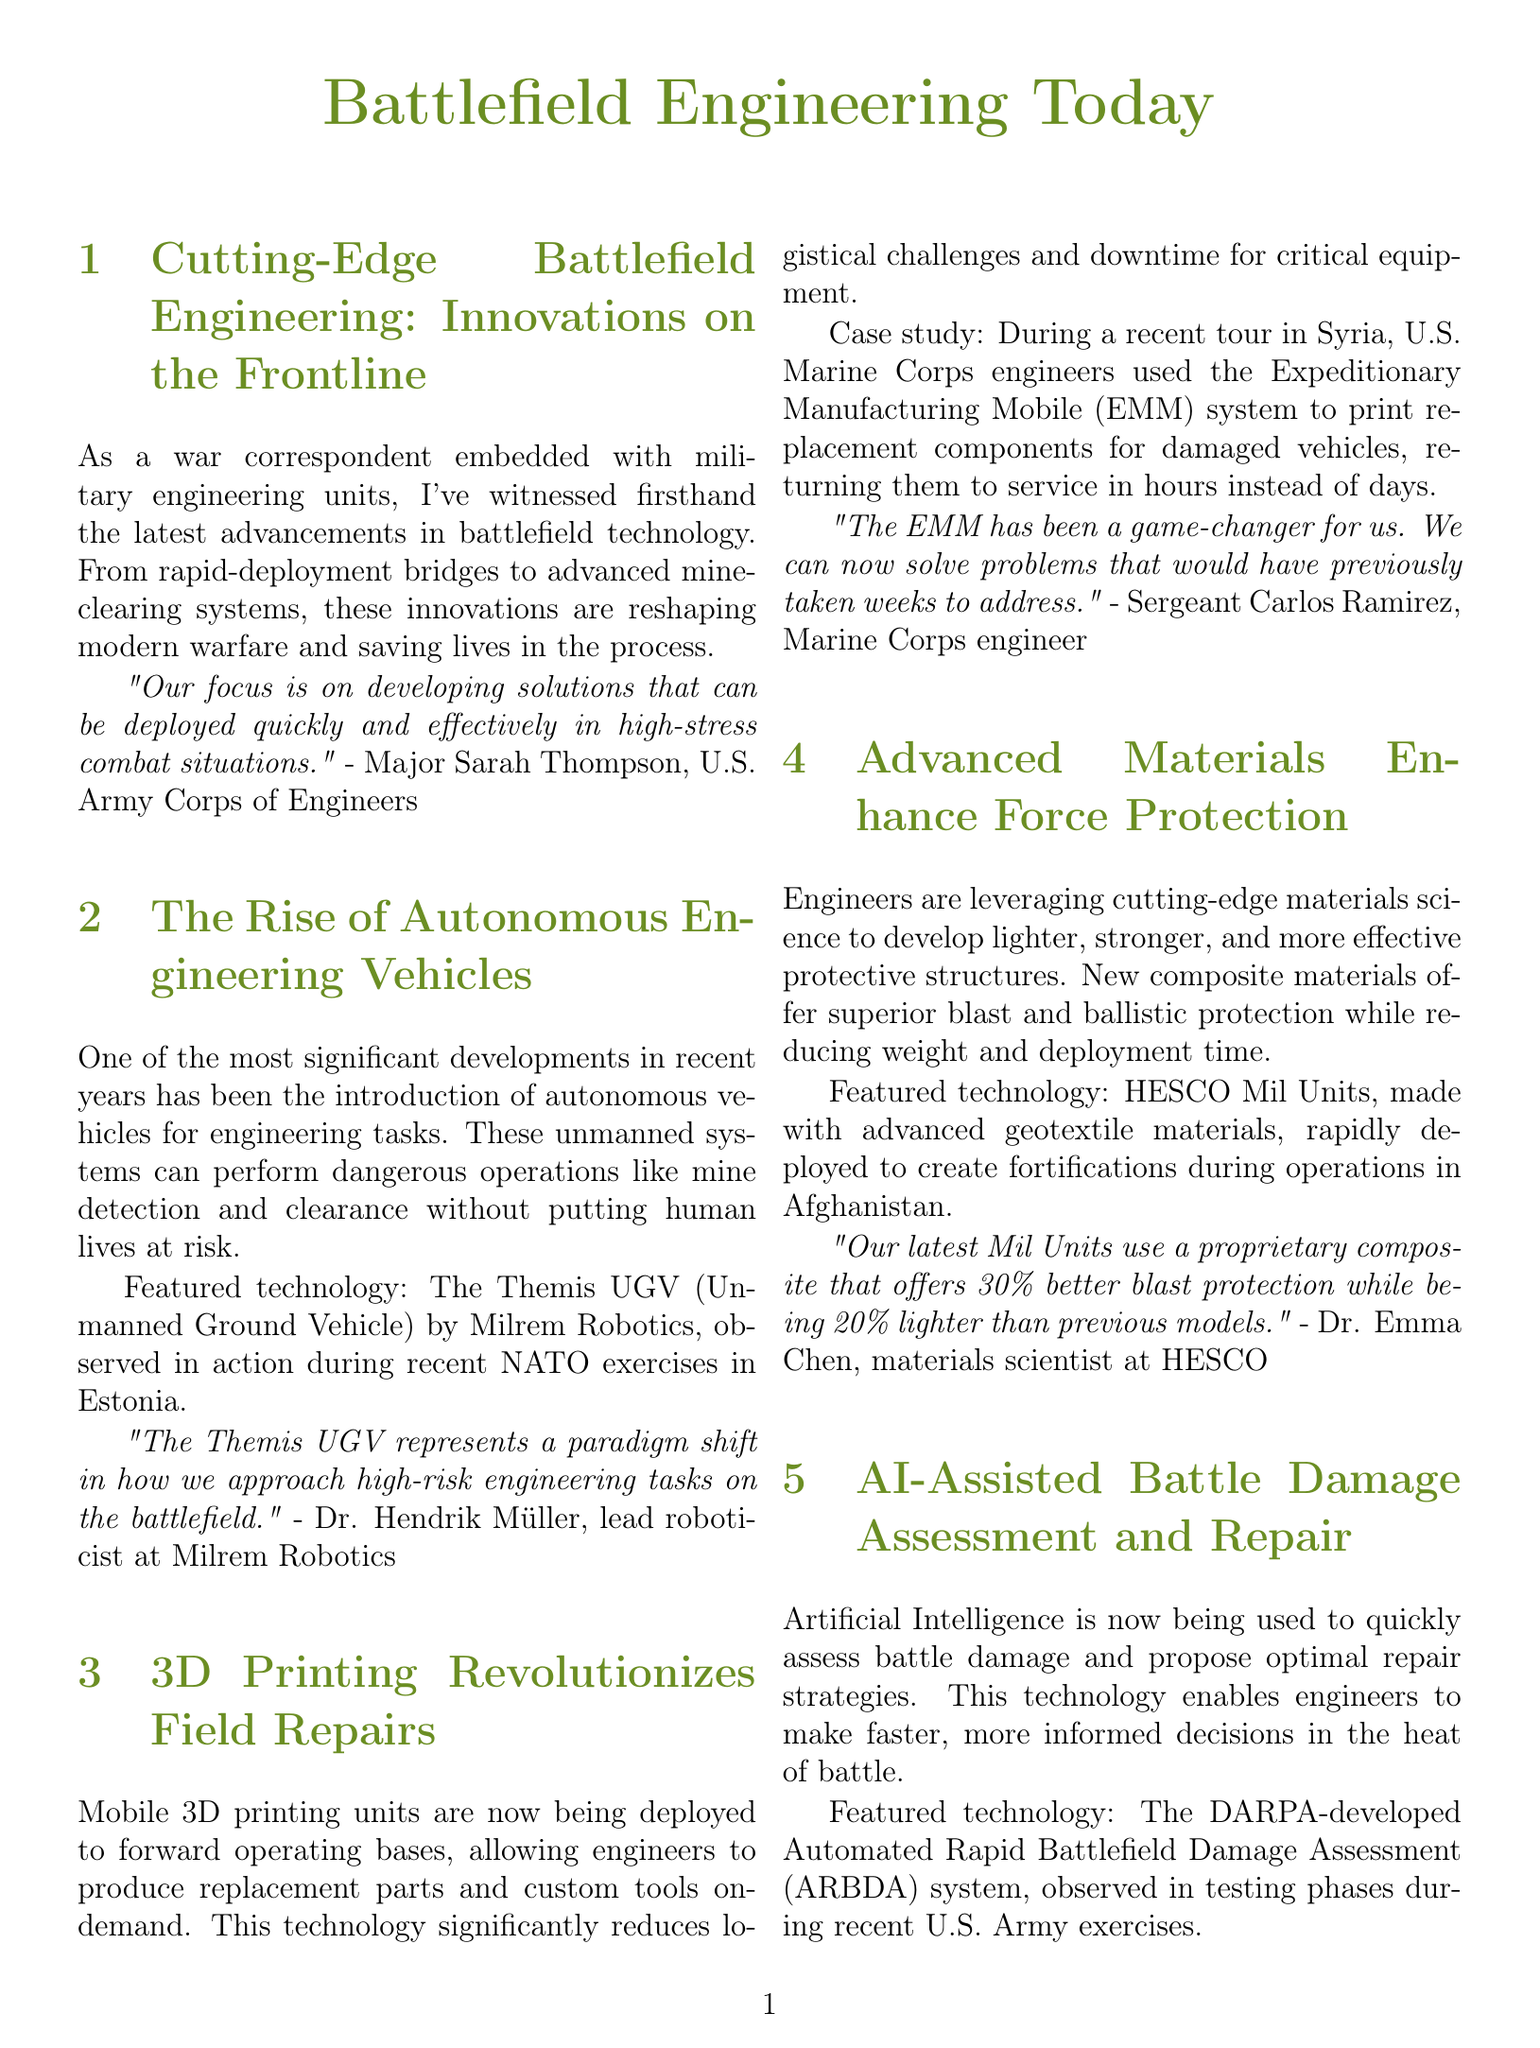What is the title of the newsletter? The title of the newsletter is found at the beginning of the document, which is "Battlefield Engineering Today."
Answer: Battlefield Engineering Today Who provided the quote about developing solutions in high-stress combat situations? The quote is attributed to Major Sarah Thompson, who is part of the U.S. Army Corps of Engineers.
Answer: Major Sarah Thompson What is the featured technology mentioned under autonomous engineering vehicles? The document refers to the "Themis UGV" as the featured technology in this section.
Answer: Themis UGV How much better blast protection do the latest Mil Units offer compared to previous models? It is stated that the new Mil Units offer "30% better blast protection."
Answer: 30% Who is the lead roboticist at Milrem Robotics? The document specifies that Dr. Hendrik Müller holds this position.
Answer: Dr. Hendrik Müller What major advantage does the Expeditionary Manufacturing Mobile system provide? The document highlights that it allows engineers to print replacement components, significantly reducing downtime.
Answer: Game-changer for us What technology is mentioned for battle damage assessment and repair? The automated system referred to in the document is the "Automated Rapid Battlefield Damage Assessment (ARBDA)."
Answer: ARBDA What is the focus of AI technologies in battlefield engineering according to the newsletter? The focus of AI technologies is to quickly assess battle damage and propose optimal repair strategies.
Answer: Assess battle damage Who is the author of the newsletter? The author of the newsletter is noted at the end, and their name is Alex Martinez.
Answer: Alex Martinez What industry does the author specialize in? The author specializes in military technology and innovation.
Answer: Military technology and innovation 